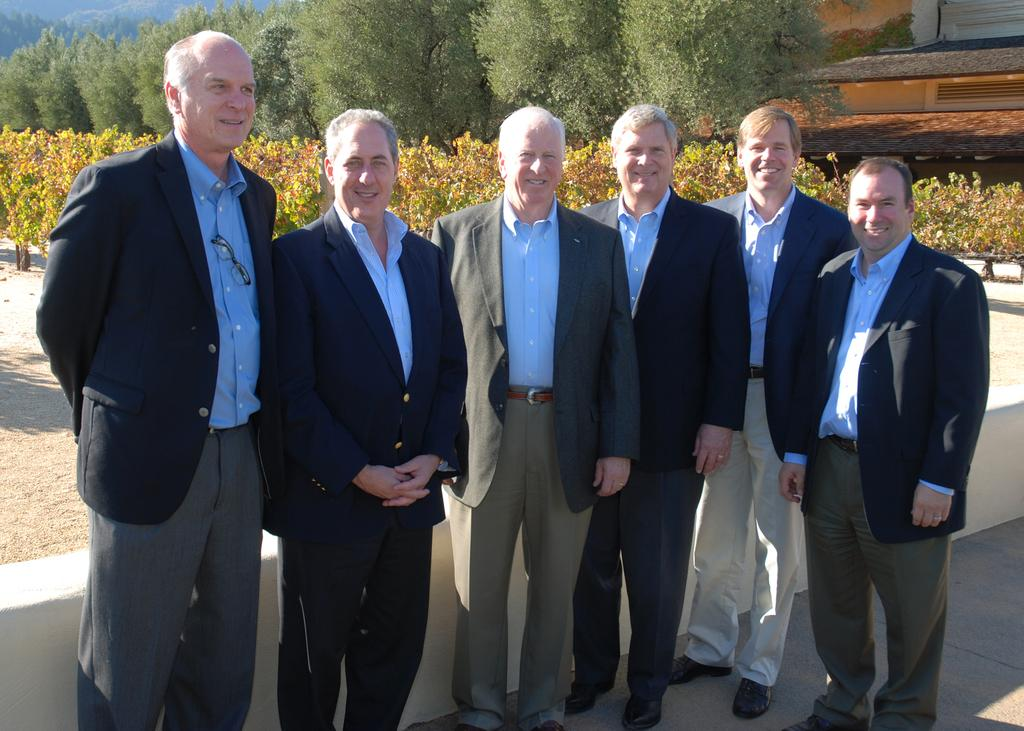What are the persons in the image doing? The persons in the image are standing and smiling. What can be seen behind the persons? There is a wall visible behind the persons. What is located behind the wall? Plants, trees, and buildings are present behind the wall. What type of cracker is being used to patch the wall in the image? There is no cracker or patching activity present in the image. 